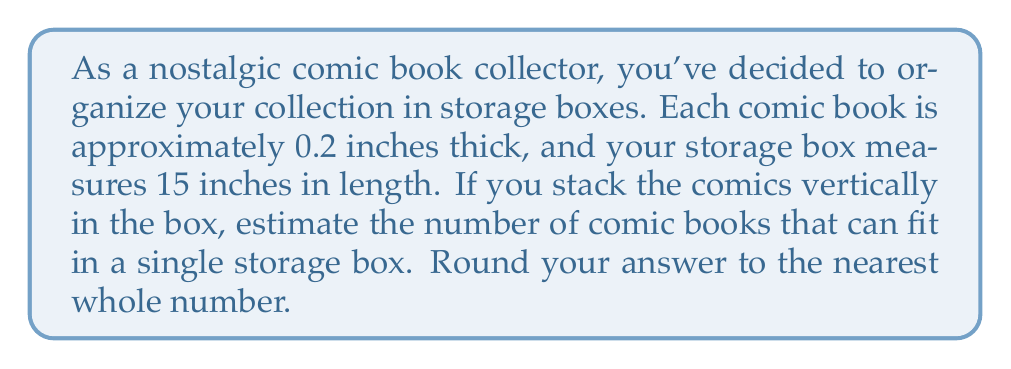Solve this math problem. To estimate the number of comic books that can fit in the storage box, we need to use the concept of division. Let's break down the problem step-by-step:

1. Identify the given information:
   - Each comic book is approximately 0.2 inches thick
   - The storage box is 15 inches long

2. Set up the division equation:
   $$ \text{Number of comics} = \frac{\text{Box length}}{\text{Comic thickness}} $$

3. Plug in the values:
   $$ \text{Number of comics} = \frac{15 \text{ inches}}{0.2 \text{ inches per comic}} $$

4. Perform the division:
   $$ \text{Number of comics} = 15 \div 0.2 = 75 $$

5. Round to the nearest whole number:
   The result is already a whole number, so no rounding is necessary.

Note: This estimation assumes that the comics fit perfectly in the box without any extra space. In reality, you might fit slightly fewer comics due to variations in comic book thickness and the need for some wiggle room when removing or inserting comics.
Answer: Approximately 75 comic books can fit in the storage box. 